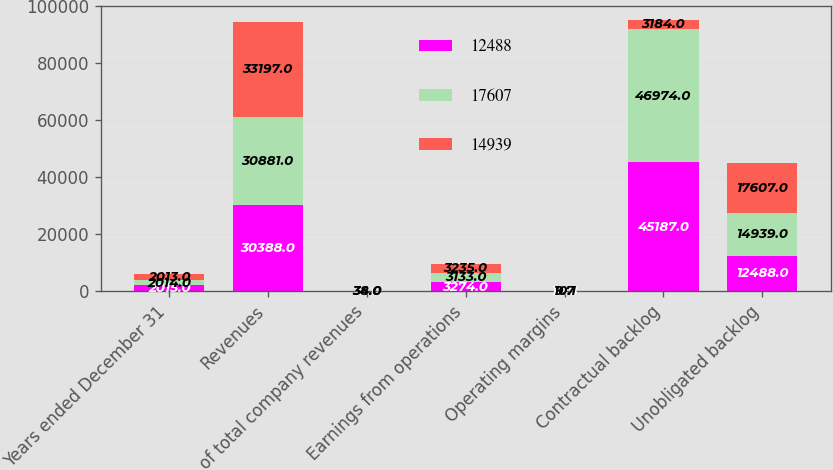<chart> <loc_0><loc_0><loc_500><loc_500><stacked_bar_chart><ecel><fcel>Years ended December 31<fcel>Revenues<fcel>of total company revenues<fcel>Earnings from operations<fcel>Operating margins<fcel>Contractual backlog<fcel>Unobligated backlog<nl><fcel>12488<fcel>2015<fcel>30388<fcel>32<fcel>3274<fcel>10.8<fcel>45187<fcel>12488<nl><fcel>17607<fcel>2014<fcel>30881<fcel>34<fcel>3133<fcel>10.1<fcel>46974<fcel>14939<nl><fcel>14939<fcel>2013<fcel>33197<fcel>38<fcel>3235<fcel>9.7<fcel>3184<fcel>17607<nl></chart> 